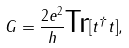<formula> <loc_0><loc_0><loc_500><loc_500>G = \frac { 2 e ^ { 2 } } { h } \text {Tr} [ t ^ { \dagger } t ] ,</formula> 